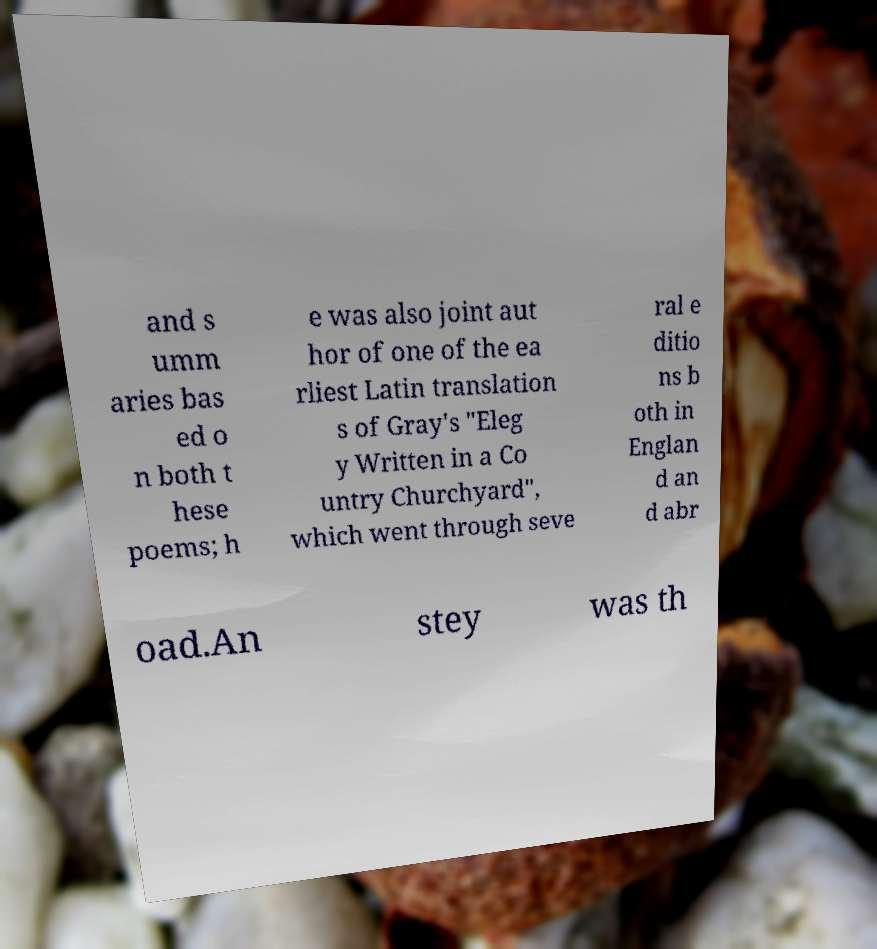Please identify and transcribe the text found in this image. and s umm aries bas ed o n both t hese poems; h e was also joint aut hor of one of the ea rliest Latin translation s of Gray's "Eleg y Written in a Co untry Churchyard", which went through seve ral e ditio ns b oth in Englan d an d abr oad.An stey was th 